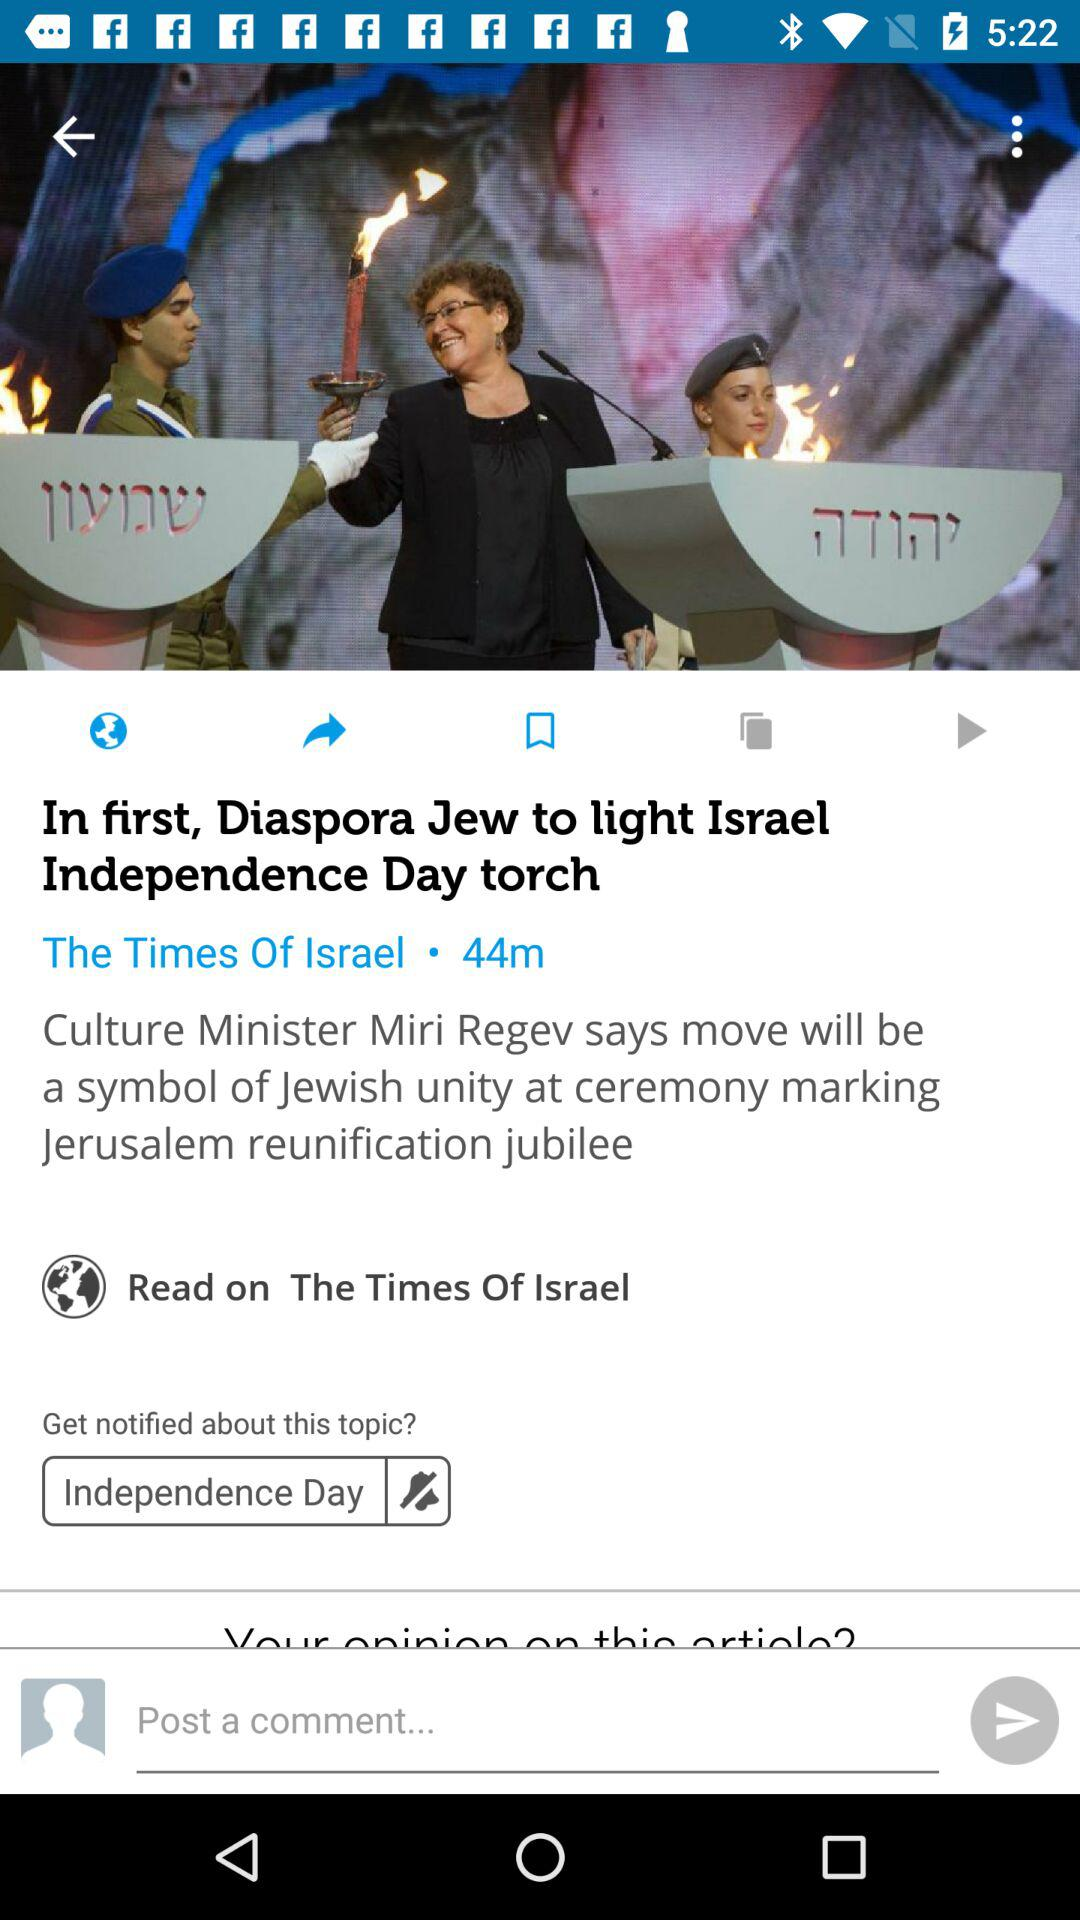Where can the news be read? The news can be read on "The Times Of Israel". 